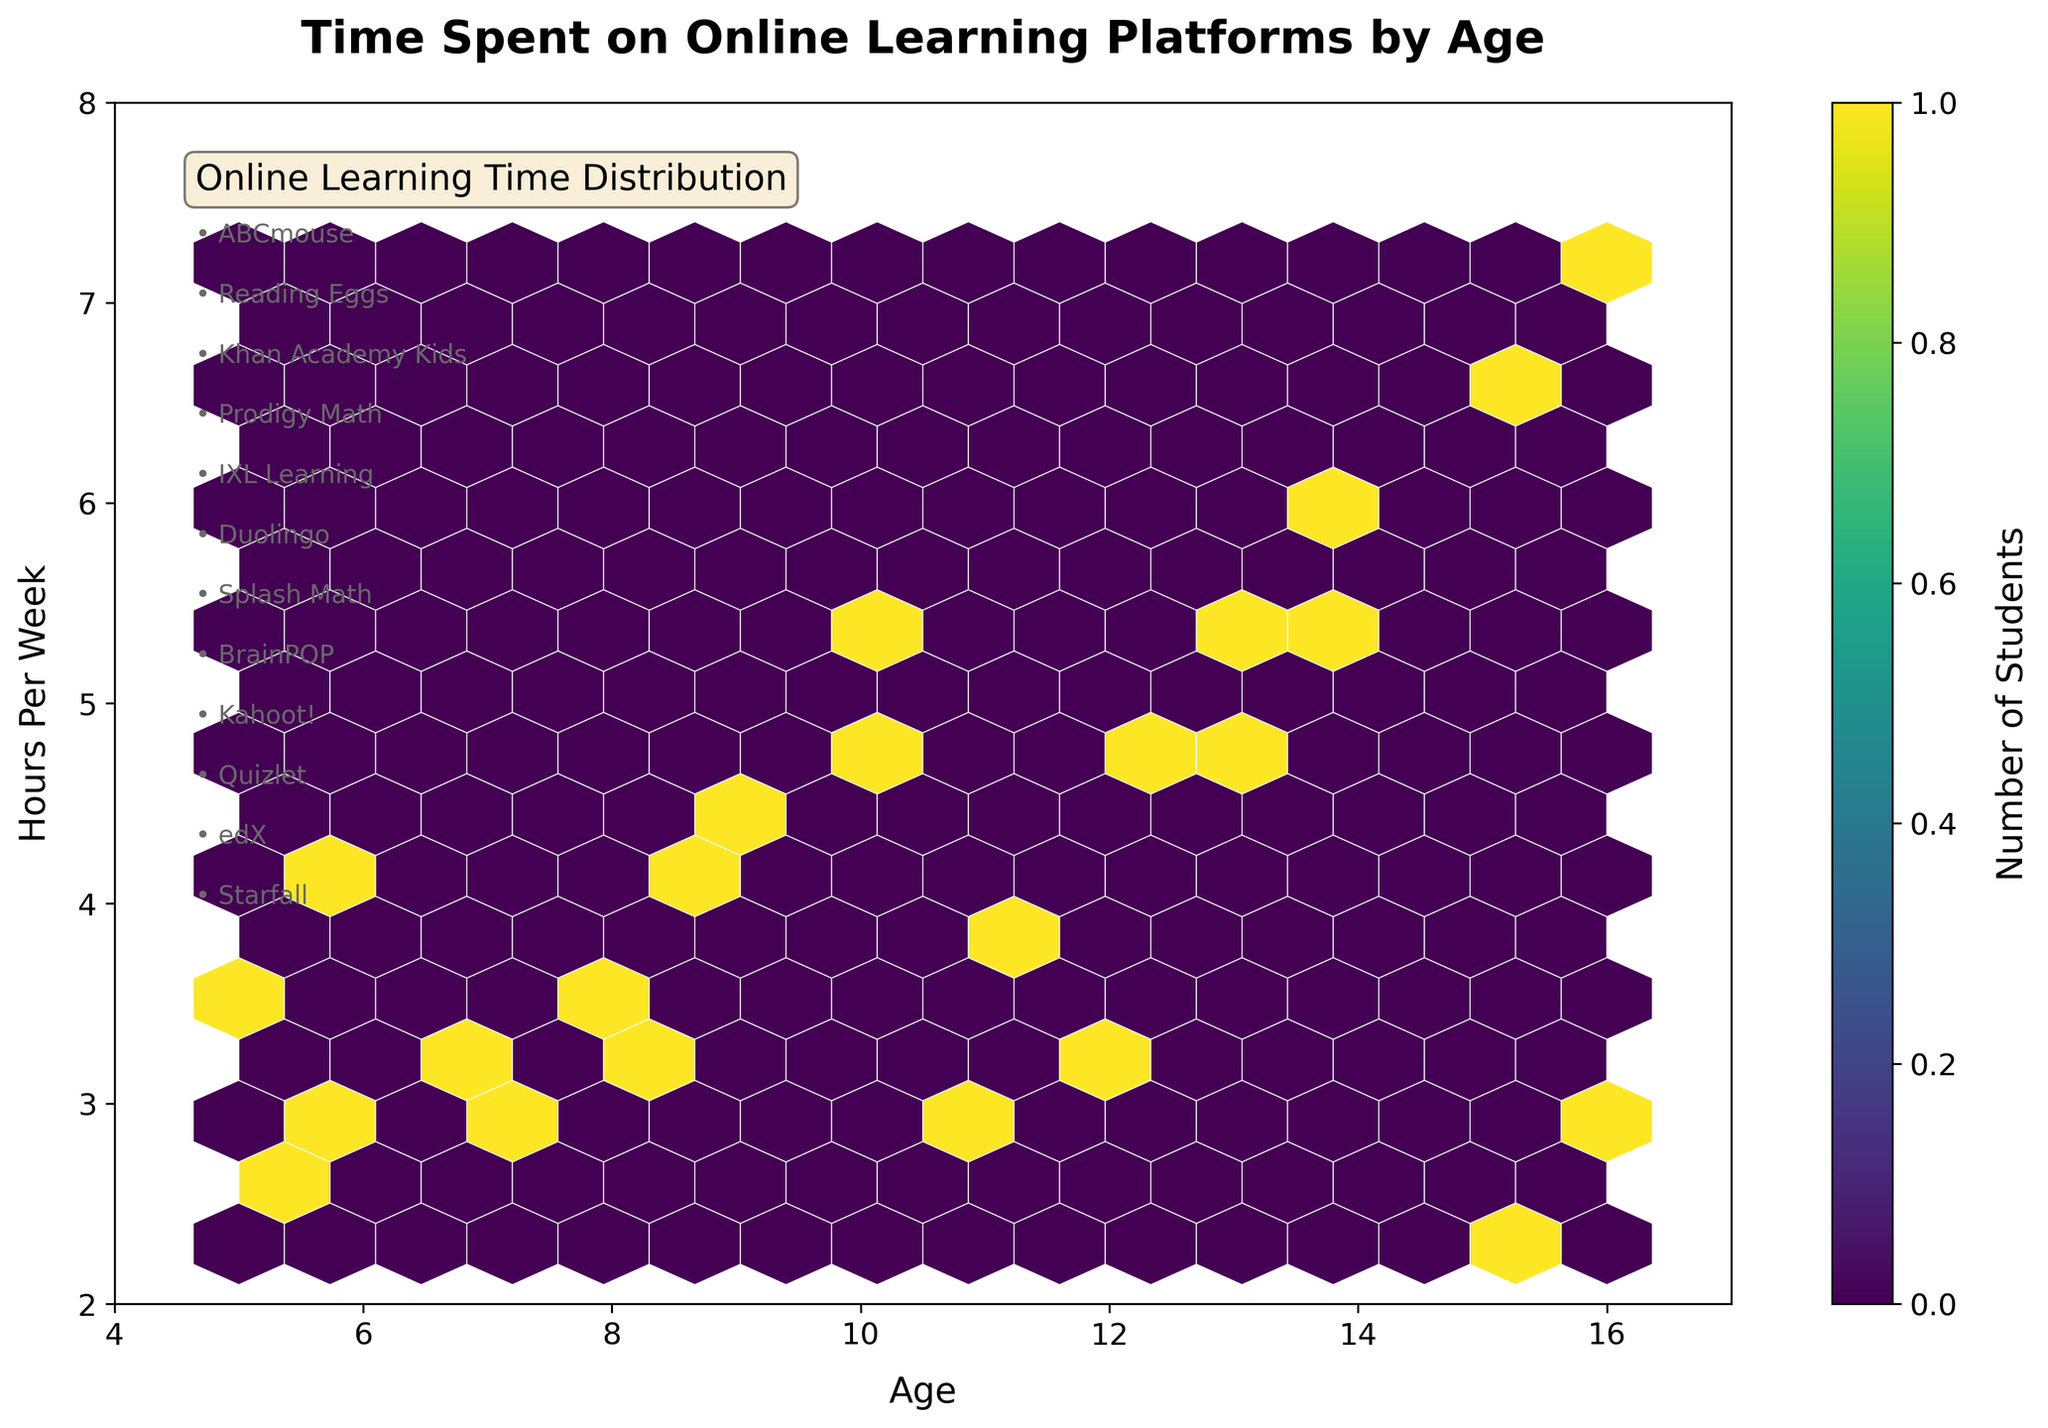what is the title of the plot? The title of the plot is located at the top in bold font, indicating the main subject. In this case, the title should be explicitly written on the figure.
Answer: Time Spent on Online Learning Platforms by Age what is the color used to represent the number of students? The color used to represent data in a hexbin plot often has a color scale bar adjacent to the plot. This plot uses the 'viridis' color map, ranging from dark blue to yellow, as seen in the color legend on the right side of the plot.
Answer: Viridis, ranging from dark blue to yellow what does the color bar on the right side represent? The color bar symbolizes the number of students represented by the density of the hexagons, with different colors indicating varying counts. The label on the color bar aids interpretation.
Answer: Number of Students what is the age range covered in the plot? The age range is shown along the x-axis, with the plot spanning values from 4 to 17. The precise age points are indicated by the data limits on the x-axis.
Answer: 5 to 16 years which age group spends the highest number of hours per week? By identifying the y-axis (Hours Per Week) and finding the highest value, we see the highest value is at the peak on the y-axis, where the maximum hours per week touches 7.2 hours. The corresponding age group on the x-axis is 16 years old.
Answer: 16 years old which platform appears related to the youngest students? Platforms associated with specific age ranges are listed on the figure. By reviewing this list, we identify 'ABCmouse' as most frequent for younger students aged 5-6.
Answer: ABCmouse how many platforms are listed on the figure? The platforms are numerically listed within the text annotations on the plot, each marked with a bullet point. By counting these bullet points, we confirm the number of different platforms.
Answer: 12 platforms what is the range of hours per week students spend on online learning platforms? By referring to the y-axis range, we observe the minimum and maximum hours spent from roughly 2 to 8 hours per week. Exact values can be confirmed by examining y-axis tick marks.
Answer: 2 to 8 hours per week do older students spend more time on online learning platforms than younger students? By comparing the data distribution along the x-axis (age) and y-axis (hours per week), the higher density of hexagons for older students tends to fall around longer hours per week compared to younger students, indicating an increasing trend with age.
Answer: Yes, older students spend more time which online learning platform has the most concentrated use for multiple age groups? By analyzing the hexagon density for each platform and identifying those covering a broader range of age groups, 'IXL Learning' appears most frequently across multiple age groups with higher density.
Answer: IXL Learning 